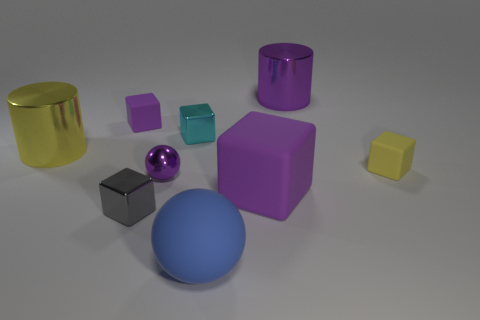The yellow metal thing has what size?
Give a very brief answer. Large. Is the size of the shiny ball the same as the yellow metallic object?
Give a very brief answer. No. What is the color of the big thing that is in front of the small purple matte thing and on the right side of the matte sphere?
Offer a very short reply. Purple. How many big cylinders have the same material as the small gray thing?
Your answer should be compact. 2. How many tiny cyan metallic balls are there?
Make the answer very short. 0. Is the size of the purple metallic sphere the same as the cylinder that is to the right of the small metallic sphere?
Make the answer very short. No. What is the material of the cube right of the purple matte thing on the right side of the tiny gray metal cube?
Your answer should be compact. Rubber. There is a yellow object on the left side of the small purple object that is behind the large shiny cylinder in front of the small purple cube; how big is it?
Give a very brief answer. Large. Do the large yellow metallic thing and the large purple thing behind the small cyan metallic cube have the same shape?
Ensure brevity in your answer.  Yes. What material is the tiny purple block?
Your answer should be compact. Rubber. 